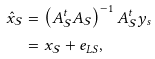<formula> <loc_0><loc_0><loc_500><loc_500>\hat { x } _ { \mathcal { S } } & = \left ( A _ { \mathcal { S } } ^ { t } A _ { \mathcal { S } } \right ) ^ { - 1 } A _ { \mathcal { S } } ^ { t } y _ { s } \\ & = x _ { \mathcal { S } } + e _ { L S } ,</formula> 